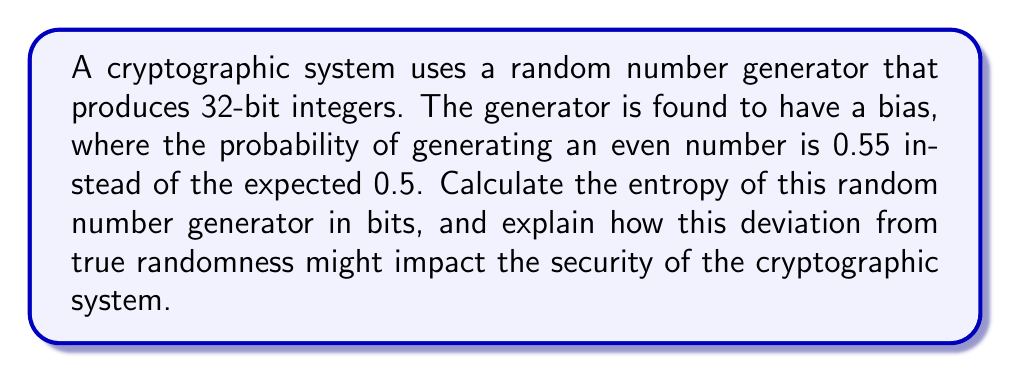Can you answer this question? Let's approach this step-by-step:

1) First, we need to understand what entropy means in this context. Entropy is a measure of the unpredictability or randomness in a system. For a truly random 32-bit integer generator, the entropy would be 32 bits.

2) In our case, we have a biased system. We need to calculate the entropy using the formula:

   $$H = -\sum_{i} p_i \log_2(p_i)$$

   where $p_i$ is the probability of each outcome.

3) We have two outcomes: even and odd numbers.
   $p(\text{even}) = 0.55$
   $p(\text{odd}) = 1 - 0.55 = 0.45$

4) Let's calculate the entropy:

   $$\begin{align*}
   H &= -[0.55 \log_2(0.55) + 0.45 \log_2(0.45)] \\
   &= -[0.55 \cdot (-0.8626) + 0.45 \cdot (-1.1520)] \\
   &= 0.4744 + 0.5184 \\
   &= 0.9928 \text{ bits}
   \end{align*}$$

5) This is the entropy per bit of the least significant bit (LSB). For the entire 32-bit number, we multiply this by 32:

   $$32 \cdot 0.9928 = 31.7696 \text{ bits}$$

6) Impact on security: The reduction in entropy from the ideal 32 bits to 31.7696 bits means the system is slightly more predictable than a truly random one. This could potentially make cryptographic operations using this generator more vulnerable to attacks. For example:

   - In encryption, it might lead to patterns in the ciphertext that could be exploited by statistical analysis.
   - In key generation, it could result in a smaller effective key space, making brute force attacks more feasible.
   - In random number-based protocols (like some digital signature schemes), it could introduce biases that an attacker might exploit.

While the impact seems small, in cryptography, even small deviations from true randomness can be significant, especially when dealing with large amounts of data or long-term security needs.
Answer: 31.7696 bits 